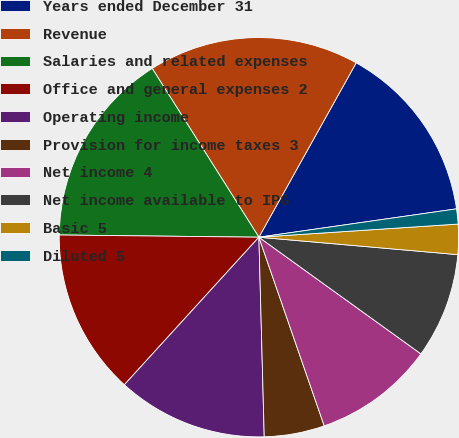Convert chart to OTSL. <chart><loc_0><loc_0><loc_500><loc_500><pie_chart><fcel>Years ended December 31<fcel>Revenue<fcel>Salaries and related expenses<fcel>Office and general expenses 2<fcel>Operating income<fcel>Provision for income taxes 3<fcel>Net income 4<fcel>Net income available to IPG<fcel>Basic 5<fcel>Diluted 5<nl><fcel>14.63%<fcel>17.07%<fcel>15.85%<fcel>13.41%<fcel>12.19%<fcel>4.88%<fcel>9.76%<fcel>8.54%<fcel>2.44%<fcel>1.22%<nl></chart> 